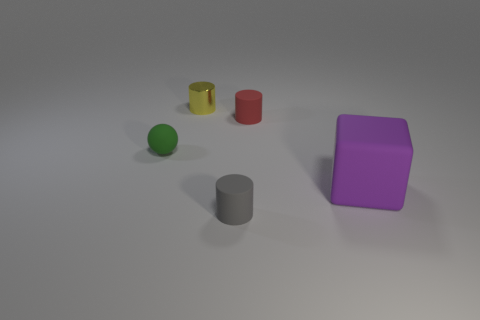Do the yellow metal thing and the red object have the same shape?
Your answer should be compact. Yes. What number of tiny red objects are behind the small object to the left of the metallic object?
Give a very brief answer. 1. There is a small yellow object that is the same shape as the small red matte object; what is it made of?
Give a very brief answer. Metal. Is the gray cylinder made of the same material as the yellow object that is on the right side of the green matte thing?
Keep it short and to the point. No. What shape is the tiny matte object that is left of the metallic cylinder?
Your answer should be compact. Sphere. What number of other things are there of the same material as the tiny gray thing
Give a very brief answer. 3. The purple matte cube is what size?
Your answer should be very brief. Large. What number of other objects are there of the same color as the metal cylinder?
Make the answer very short. 0. The small matte thing that is both in front of the small red object and on the right side of the small yellow thing is what color?
Offer a terse response. Gray. How many purple matte objects are there?
Make the answer very short. 1. 